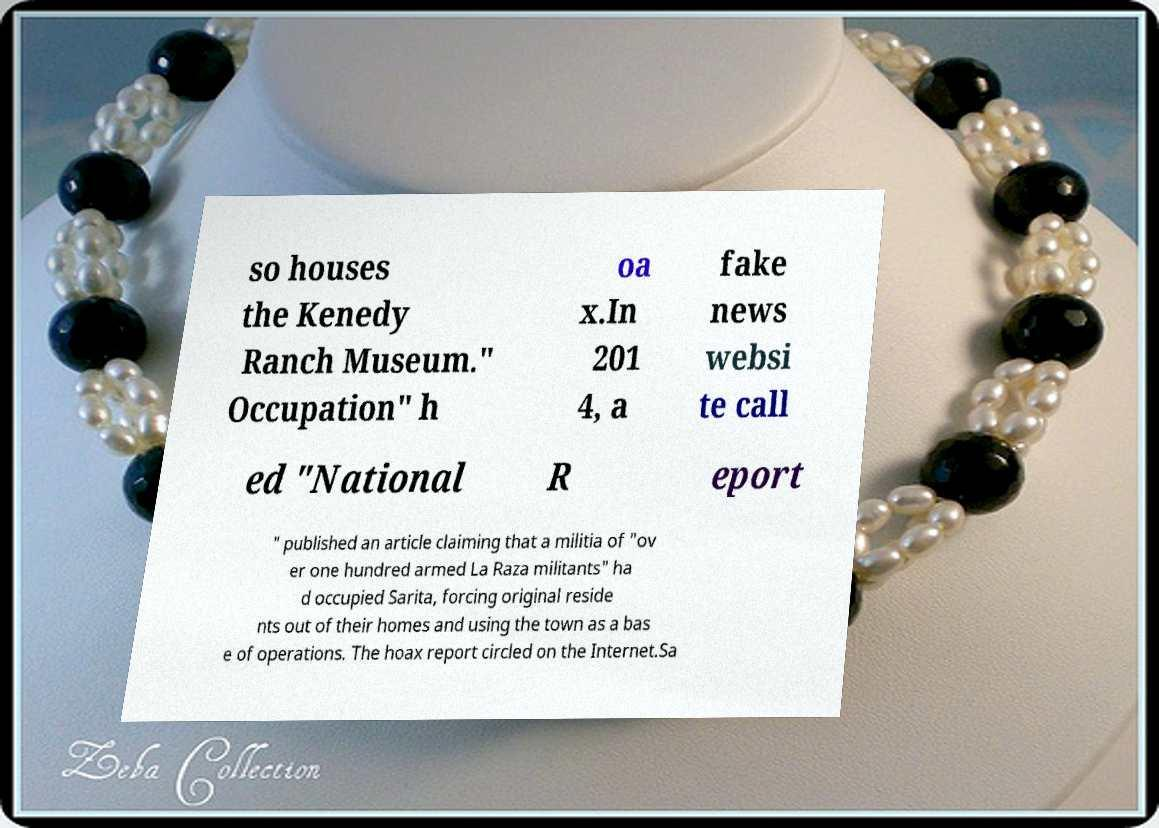Can you read and provide the text displayed in the image?This photo seems to have some interesting text. Can you extract and type it out for me? so houses the Kenedy Ranch Museum." Occupation" h oa x.In 201 4, a fake news websi te call ed "National R eport " published an article claiming that a militia of "ov er one hundred armed La Raza militants" ha d occupied Sarita, forcing original reside nts out of their homes and using the town as a bas e of operations. The hoax report circled on the Internet.Sa 